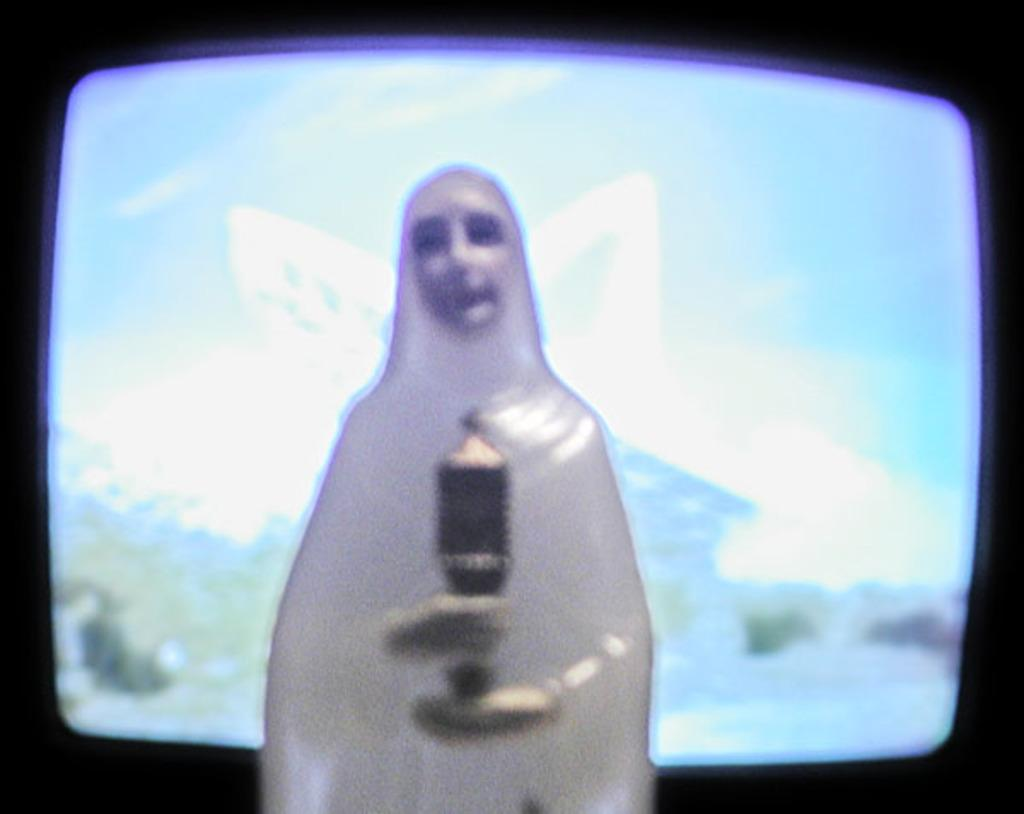What is the main subject of the image? There is a statue of a person in the image. What is the person in the statue holding? The person is holding an object in their hands. What can be seen in the background of the image? There is a TV in the background of the image. What type of sound can be heard coming from the letters in the image? There are no letters present in the image, so no sound can be heard from them. 